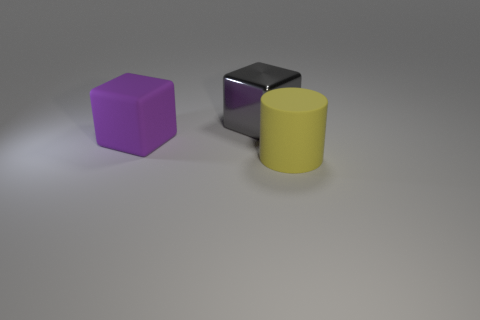Is there anything else that has the same material as the gray object?
Provide a succinct answer. No. There is a large object that is made of the same material as the large yellow cylinder; what shape is it?
Provide a short and direct response. Cube. There is a thing that is both behind the large yellow rubber thing and in front of the gray metal thing; what is its material?
Offer a very short reply. Rubber. Is there any other thing that has the same size as the yellow rubber thing?
Your response must be concise. Yes. Is the big cylinder the same color as the shiny cube?
Offer a very short reply. No. How many other big objects have the same shape as the gray metal thing?
Offer a terse response. 1. The yellow cylinder that is the same material as the big purple cube is what size?
Make the answer very short. Large. Do the metallic cube and the yellow thing have the same size?
Make the answer very short. Yes. Are there any gray shiny blocks?
Ensure brevity in your answer.  Yes. How big is the rubber thing right of the block that is on the right side of the rubber thing that is behind the yellow rubber cylinder?
Make the answer very short. Large. 